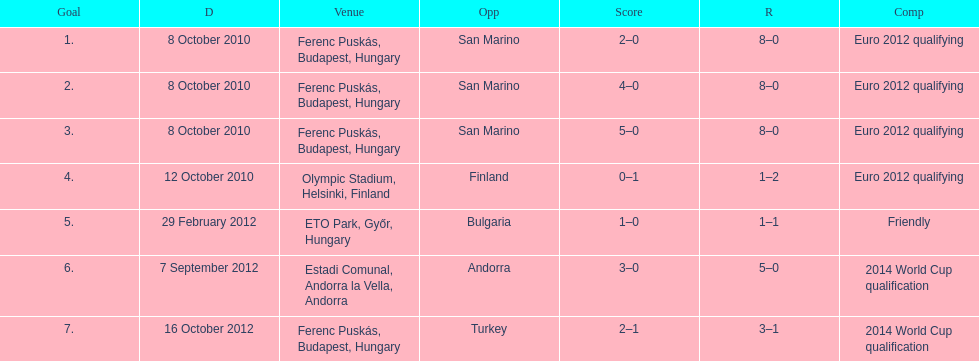Szalai scored all but one of his international goals in either euro 2012 qualifying or what other level of play? 2014 World Cup qualification. 